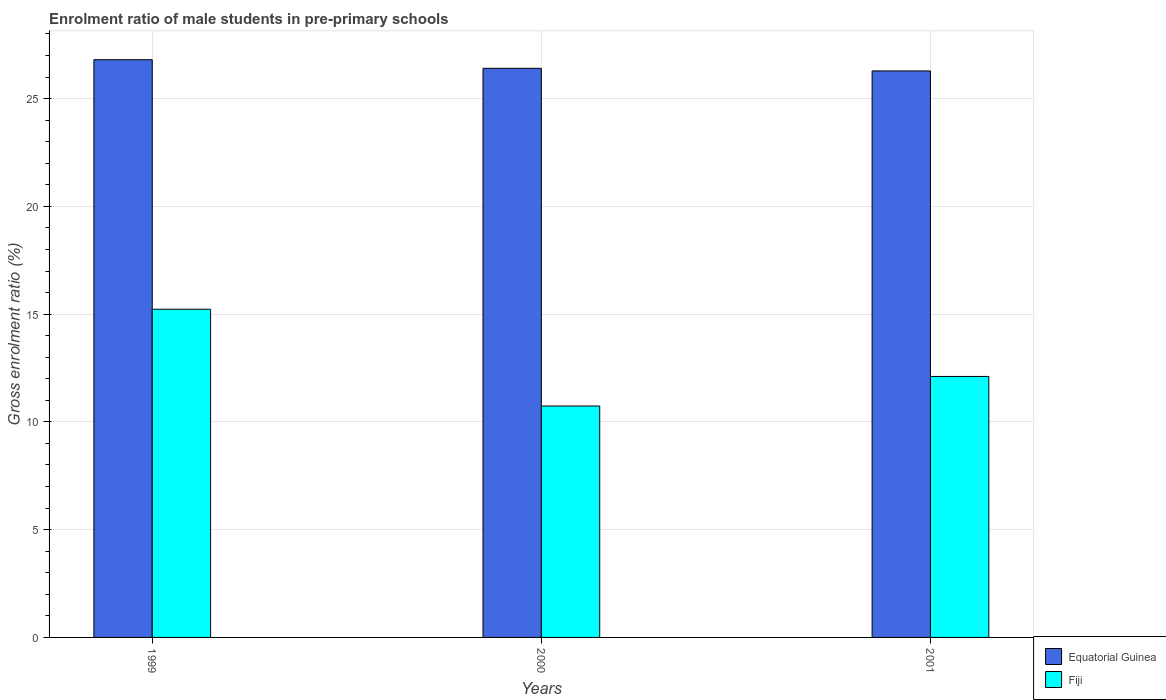Are the number of bars on each tick of the X-axis equal?
Offer a terse response. Yes. How many bars are there on the 3rd tick from the left?
Give a very brief answer. 2. What is the label of the 2nd group of bars from the left?
Your answer should be very brief. 2000. What is the enrolment ratio of male students in pre-primary schools in Equatorial Guinea in 2001?
Your response must be concise. 26.28. Across all years, what is the maximum enrolment ratio of male students in pre-primary schools in Fiji?
Give a very brief answer. 15.23. Across all years, what is the minimum enrolment ratio of male students in pre-primary schools in Fiji?
Your response must be concise. 10.74. In which year was the enrolment ratio of male students in pre-primary schools in Equatorial Guinea maximum?
Ensure brevity in your answer.  1999. In which year was the enrolment ratio of male students in pre-primary schools in Equatorial Guinea minimum?
Your answer should be very brief. 2001. What is the total enrolment ratio of male students in pre-primary schools in Equatorial Guinea in the graph?
Offer a terse response. 79.49. What is the difference between the enrolment ratio of male students in pre-primary schools in Fiji in 1999 and that in 2000?
Keep it short and to the point. 4.49. What is the difference between the enrolment ratio of male students in pre-primary schools in Fiji in 2000 and the enrolment ratio of male students in pre-primary schools in Equatorial Guinea in 2001?
Your answer should be very brief. -15.55. What is the average enrolment ratio of male students in pre-primary schools in Fiji per year?
Keep it short and to the point. 12.69. In the year 2000, what is the difference between the enrolment ratio of male students in pre-primary schools in Equatorial Guinea and enrolment ratio of male students in pre-primary schools in Fiji?
Ensure brevity in your answer.  15.67. What is the ratio of the enrolment ratio of male students in pre-primary schools in Fiji in 1999 to that in 2000?
Your answer should be very brief. 1.42. What is the difference between the highest and the second highest enrolment ratio of male students in pre-primary schools in Equatorial Guinea?
Provide a succinct answer. 0.4. What is the difference between the highest and the lowest enrolment ratio of male students in pre-primary schools in Equatorial Guinea?
Your answer should be compact. 0.52. In how many years, is the enrolment ratio of male students in pre-primary schools in Equatorial Guinea greater than the average enrolment ratio of male students in pre-primary schools in Equatorial Guinea taken over all years?
Your answer should be compact. 1. Is the sum of the enrolment ratio of male students in pre-primary schools in Fiji in 1999 and 2001 greater than the maximum enrolment ratio of male students in pre-primary schools in Equatorial Guinea across all years?
Ensure brevity in your answer.  Yes. What does the 1st bar from the left in 1999 represents?
Ensure brevity in your answer.  Equatorial Guinea. What does the 2nd bar from the right in 1999 represents?
Your answer should be compact. Equatorial Guinea. How many bars are there?
Your answer should be very brief. 6. Are all the bars in the graph horizontal?
Your answer should be very brief. No. How many years are there in the graph?
Ensure brevity in your answer.  3. How many legend labels are there?
Provide a short and direct response. 2. How are the legend labels stacked?
Provide a succinct answer. Vertical. What is the title of the graph?
Provide a succinct answer. Enrolment ratio of male students in pre-primary schools. What is the label or title of the X-axis?
Keep it short and to the point. Years. What is the label or title of the Y-axis?
Ensure brevity in your answer.  Gross enrolment ratio (%). What is the Gross enrolment ratio (%) of Equatorial Guinea in 1999?
Keep it short and to the point. 26.8. What is the Gross enrolment ratio (%) of Fiji in 1999?
Keep it short and to the point. 15.23. What is the Gross enrolment ratio (%) of Equatorial Guinea in 2000?
Offer a terse response. 26.4. What is the Gross enrolment ratio (%) in Fiji in 2000?
Make the answer very short. 10.74. What is the Gross enrolment ratio (%) in Equatorial Guinea in 2001?
Keep it short and to the point. 26.28. What is the Gross enrolment ratio (%) of Fiji in 2001?
Keep it short and to the point. 12.11. Across all years, what is the maximum Gross enrolment ratio (%) of Equatorial Guinea?
Give a very brief answer. 26.8. Across all years, what is the maximum Gross enrolment ratio (%) in Fiji?
Give a very brief answer. 15.23. Across all years, what is the minimum Gross enrolment ratio (%) in Equatorial Guinea?
Offer a very short reply. 26.28. Across all years, what is the minimum Gross enrolment ratio (%) in Fiji?
Give a very brief answer. 10.74. What is the total Gross enrolment ratio (%) in Equatorial Guinea in the graph?
Provide a short and direct response. 79.49. What is the total Gross enrolment ratio (%) in Fiji in the graph?
Your answer should be very brief. 38.07. What is the difference between the Gross enrolment ratio (%) of Equatorial Guinea in 1999 and that in 2000?
Your answer should be very brief. 0.4. What is the difference between the Gross enrolment ratio (%) in Fiji in 1999 and that in 2000?
Make the answer very short. 4.49. What is the difference between the Gross enrolment ratio (%) of Equatorial Guinea in 1999 and that in 2001?
Provide a succinct answer. 0.52. What is the difference between the Gross enrolment ratio (%) in Fiji in 1999 and that in 2001?
Your answer should be very brief. 3.12. What is the difference between the Gross enrolment ratio (%) in Equatorial Guinea in 2000 and that in 2001?
Provide a succinct answer. 0.12. What is the difference between the Gross enrolment ratio (%) of Fiji in 2000 and that in 2001?
Offer a very short reply. -1.37. What is the difference between the Gross enrolment ratio (%) of Equatorial Guinea in 1999 and the Gross enrolment ratio (%) of Fiji in 2000?
Provide a succinct answer. 16.07. What is the difference between the Gross enrolment ratio (%) in Equatorial Guinea in 1999 and the Gross enrolment ratio (%) in Fiji in 2001?
Provide a succinct answer. 14.69. What is the difference between the Gross enrolment ratio (%) in Equatorial Guinea in 2000 and the Gross enrolment ratio (%) in Fiji in 2001?
Keep it short and to the point. 14.3. What is the average Gross enrolment ratio (%) in Equatorial Guinea per year?
Give a very brief answer. 26.5. What is the average Gross enrolment ratio (%) of Fiji per year?
Give a very brief answer. 12.69. In the year 1999, what is the difference between the Gross enrolment ratio (%) of Equatorial Guinea and Gross enrolment ratio (%) of Fiji?
Provide a short and direct response. 11.58. In the year 2000, what is the difference between the Gross enrolment ratio (%) of Equatorial Guinea and Gross enrolment ratio (%) of Fiji?
Offer a very short reply. 15.67. In the year 2001, what is the difference between the Gross enrolment ratio (%) in Equatorial Guinea and Gross enrolment ratio (%) in Fiji?
Your answer should be compact. 14.17. What is the ratio of the Gross enrolment ratio (%) of Equatorial Guinea in 1999 to that in 2000?
Make the answer very short. 1.02. What is the ratio of the Gross enrolment ratio (%) of Fiji in 1999 to that in 2000?
Offer a very short reply. 1.42. What is the ratio of the Gross enrolment ratio (%) in Equatorial Guinea in 1999 to that in 2001?
Keep it short and to the point. 1.02. What is the ratio of the Gross enrolment ratio (%) in Fiji in 1999 to that in 2001?
Offer a terse response. 1.26. What is the ratio of the Gross enrolment ratio (%) in Fiji in 2000 to that in 2001?
Your answer should be compact. 0.89. What is the difference between the highest and the second highest Gross enrolment ratio (%) in Equatorial Guinea?
Your answer should be very brief. 0.4. What is the difference between the highest and the second highest Gross enrolment ratio (%) of Fiji?
Give a very brief answer. 3.12. What is the difference between the highest and the lowest Gross enrolment ratio (%) of Equatorial Guinea?
Your response must be concise. 0.52. What is the difference between the highest and the lowest Gross enrolment ratio (%) of Fiji?
Keep it short and to the point. 4.49. 